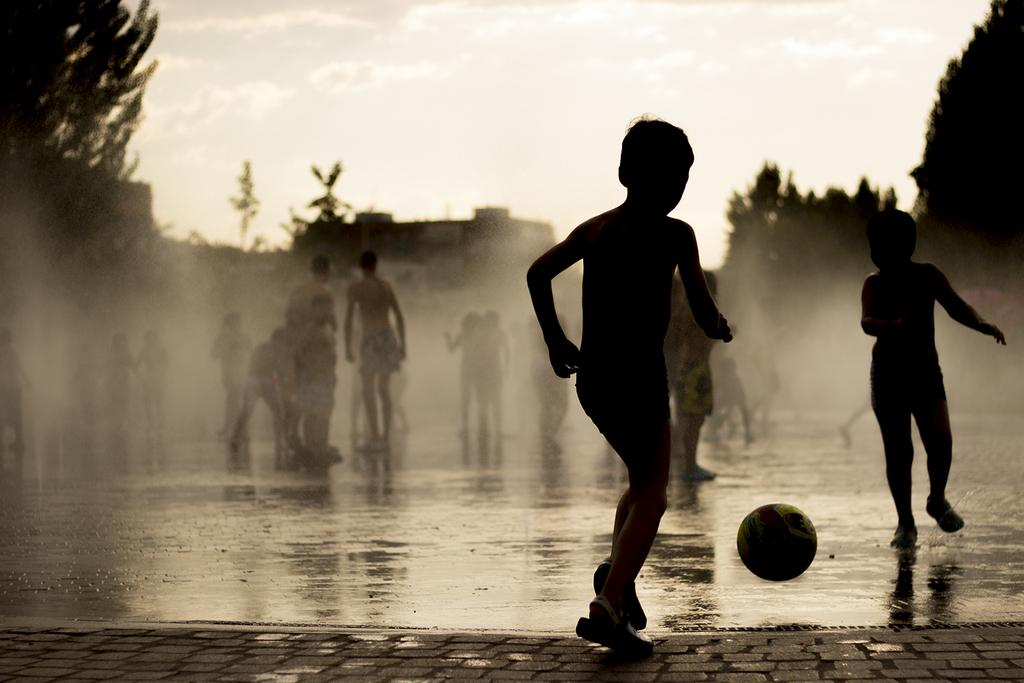What is the color scheme of the image? The image is black and white. What are the people on the ground doing in the image? Some people are playing with a ball. What other elements can be seen in the image besides people? There are buildings and trees in the image. Can you tell me how many hydrants are visible in the image? There are no hydrants present in the image. What type of sea can be seen in the background of the image? There is no sea visible in the image; it is a black and white scene with people, buildings, and trees. 